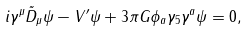Convert formula to latex. <formula><loc_0><loc_0><loc_500><loc_500>i \gamma ^ { \mu } \tilde { D } _ { \mu } \psi - V ^ { \prime } \psi + 3 \pi G \phi _ { a } \gamma _ { 5 } \gamma ^ { a } \psi = 0 ,</formula> 